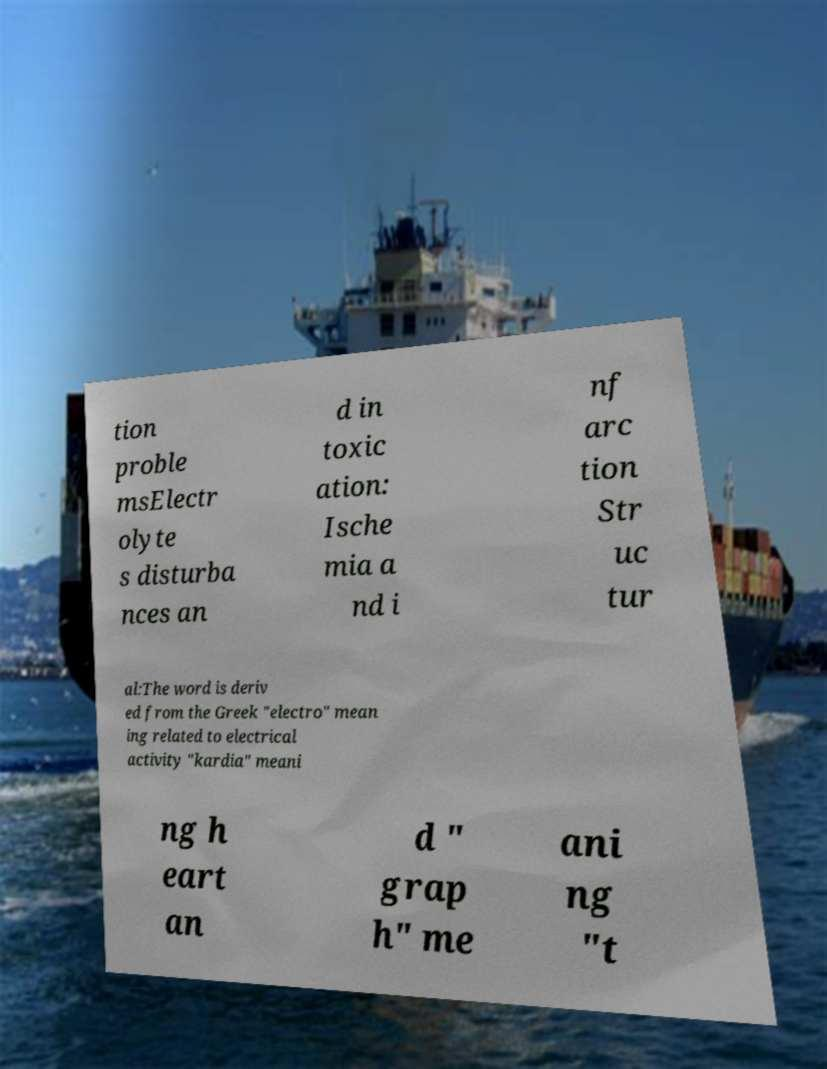Can you read and provide the text displayed in the image?This photo seems to have some interesting text. Can you extract and type it out for me? tion proble msElectr olyte s disturba nces an d in toxic ation: Ische mia a nd i nf arc tion Str uc tur al:The word is deriv ed from the Greek "electro" mean ing related to electrical activity "kardia" meani ng h eart an d " grap h" me ani ng "t 